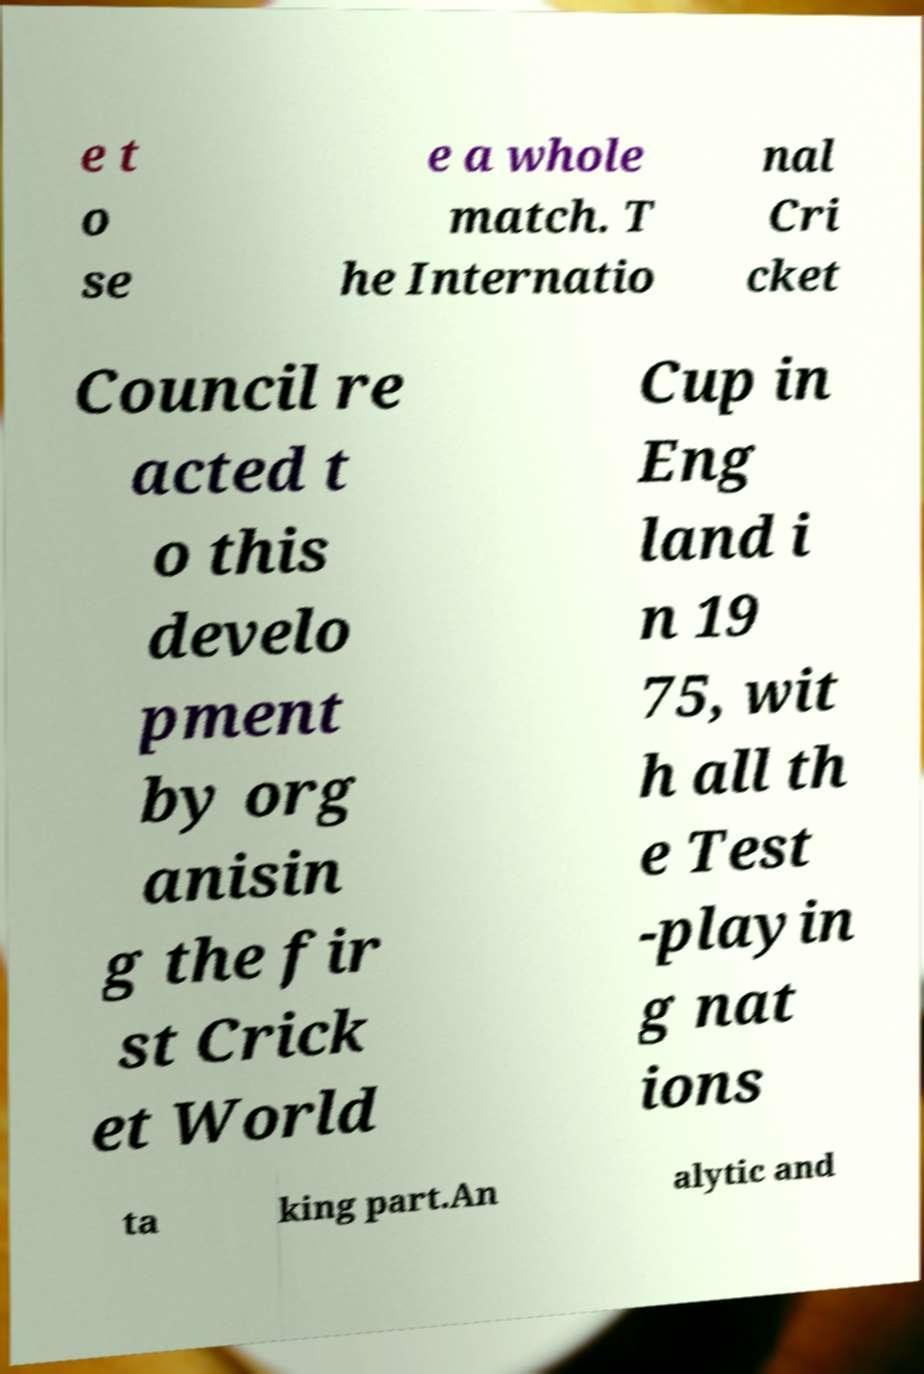Please identify and transcribe the text found in this image. e t o se e a whole match. T he Internatio nal Cri cket Council re acted t o this develo pment by org anisin g the fir st Crick et World Cup in Eng land i n 19 75, wit h all th e Test -playin g nat ions ta king part.An alytic and 